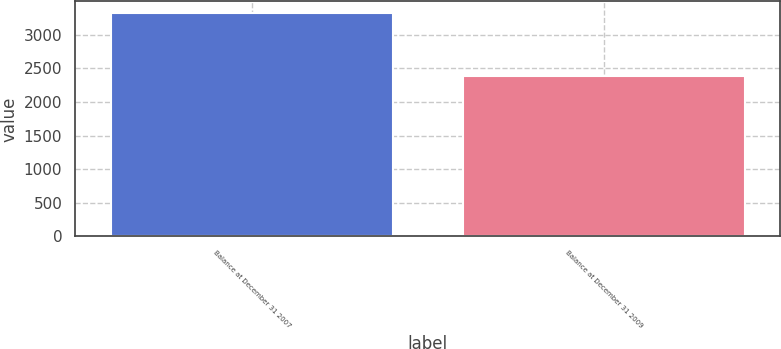Convert chart to OTSL. <chart><loc_0><loc_0><loc_500><loc_500><bar_chart><fcel>Balance at December 31 2007<fcel>Balance at December 31 2009<nl><fcel>3327<fcel>2380<nl></chart> 